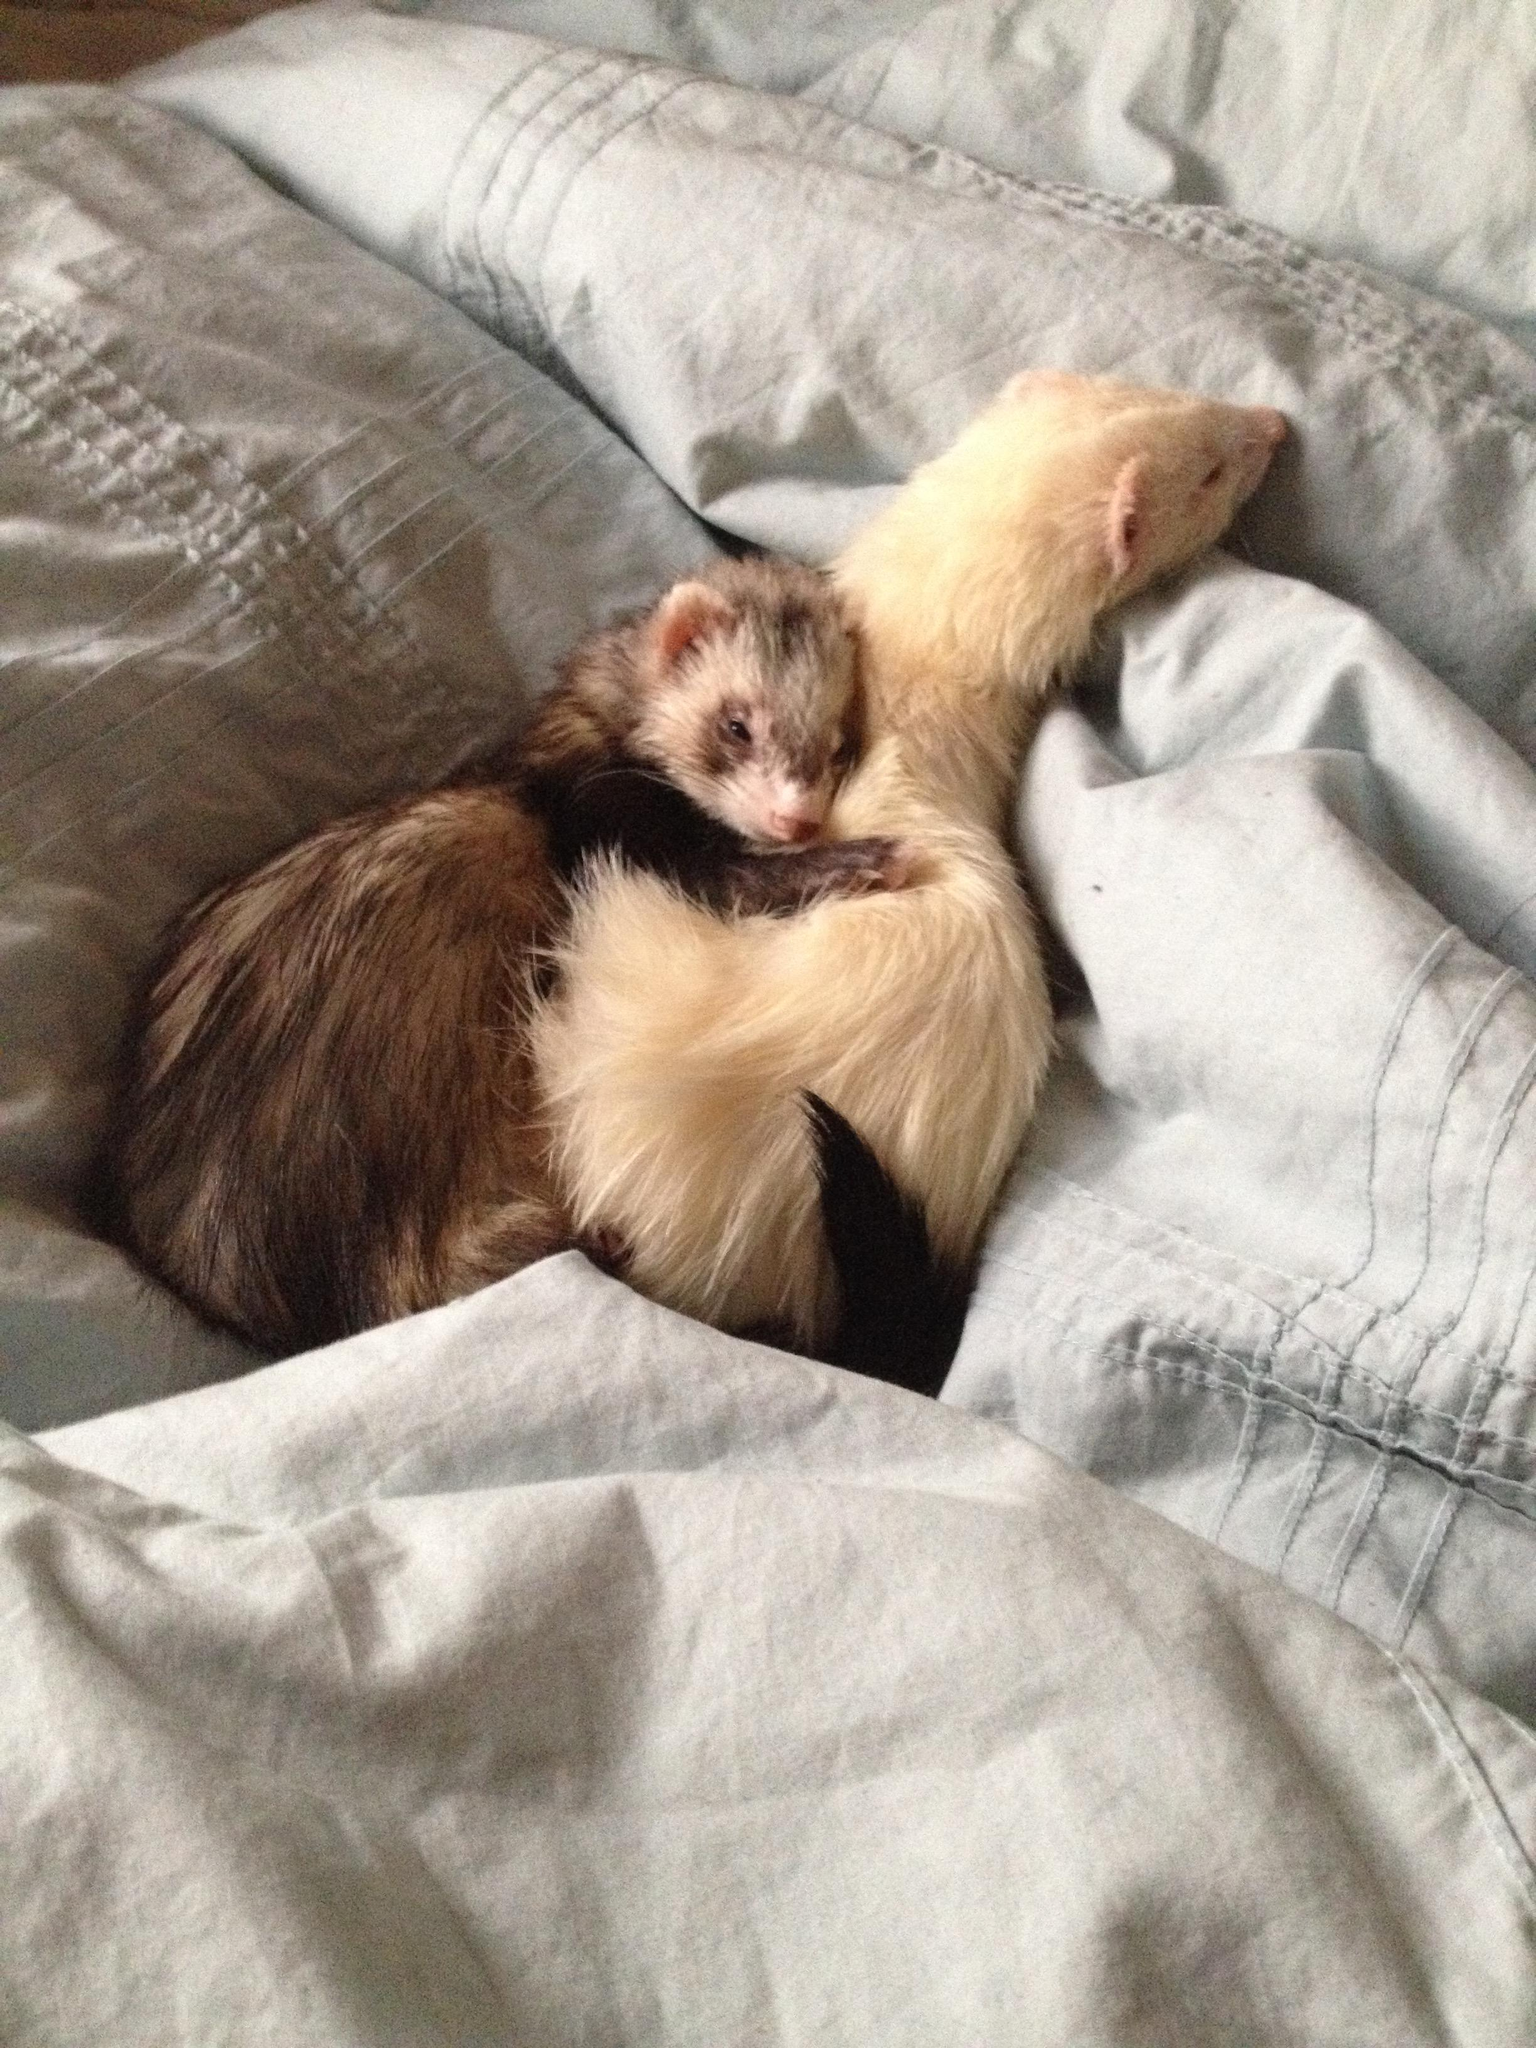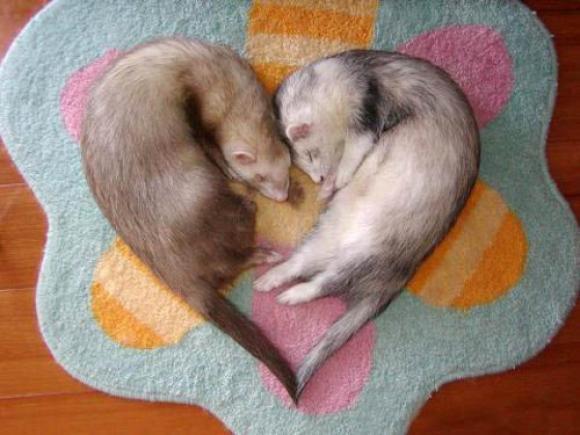The first image is the image on the left, the second image is the image on the right. Considering the images on both sides, is "An image shows two ferrets snuggling to form a ball shape face-to-face." valid? Answer yes or no. No. 